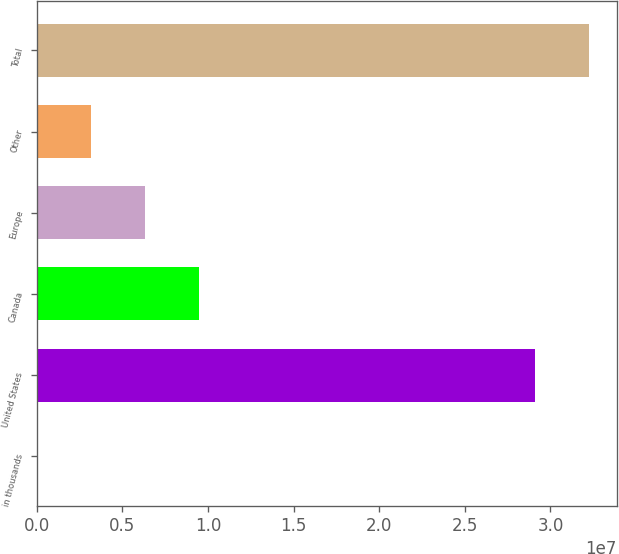Convert chart to OTSL. <chart><loc_0><loc_0><loc_500><loc_500><bar_chart><fcel>in thousands<fcel>United States<fcel>Canada<fcel>Europe<fcel>Other<fcel>Total<nl><fcel>2016<fcel>2.91122e+07<fcel>9.4475e+06<fcel>6.29901e+06<fcel>3.15051e+06<fcel>3.22607e+07<nl></chart> 